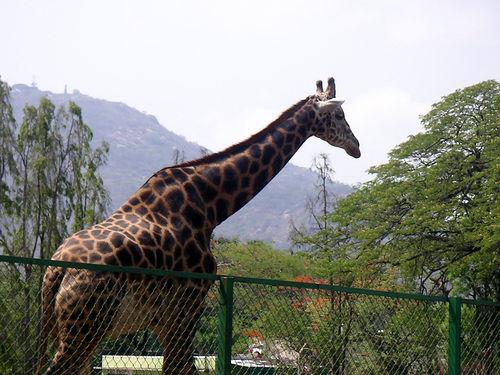What color is the fence?
Quick response, please. Green. Are the animals in the wild or in a zoo?
Quick response, please. Zoo. Are the giraffes in a cage?
Answer briefly. Yes. Was this picture taken in the wild?
Be succinct. No. What type of animal is in the photo?
Concise answer only. Giraffe. How many giraffes are there?
Concise answer only. 1. How many giraffes are in the image?
Concise answer only. 1. What direction of the frame is the giraffe facing?
Give a very brief answer. Right. How many giraffes are in the cage?
Write a very short answer. 1. 